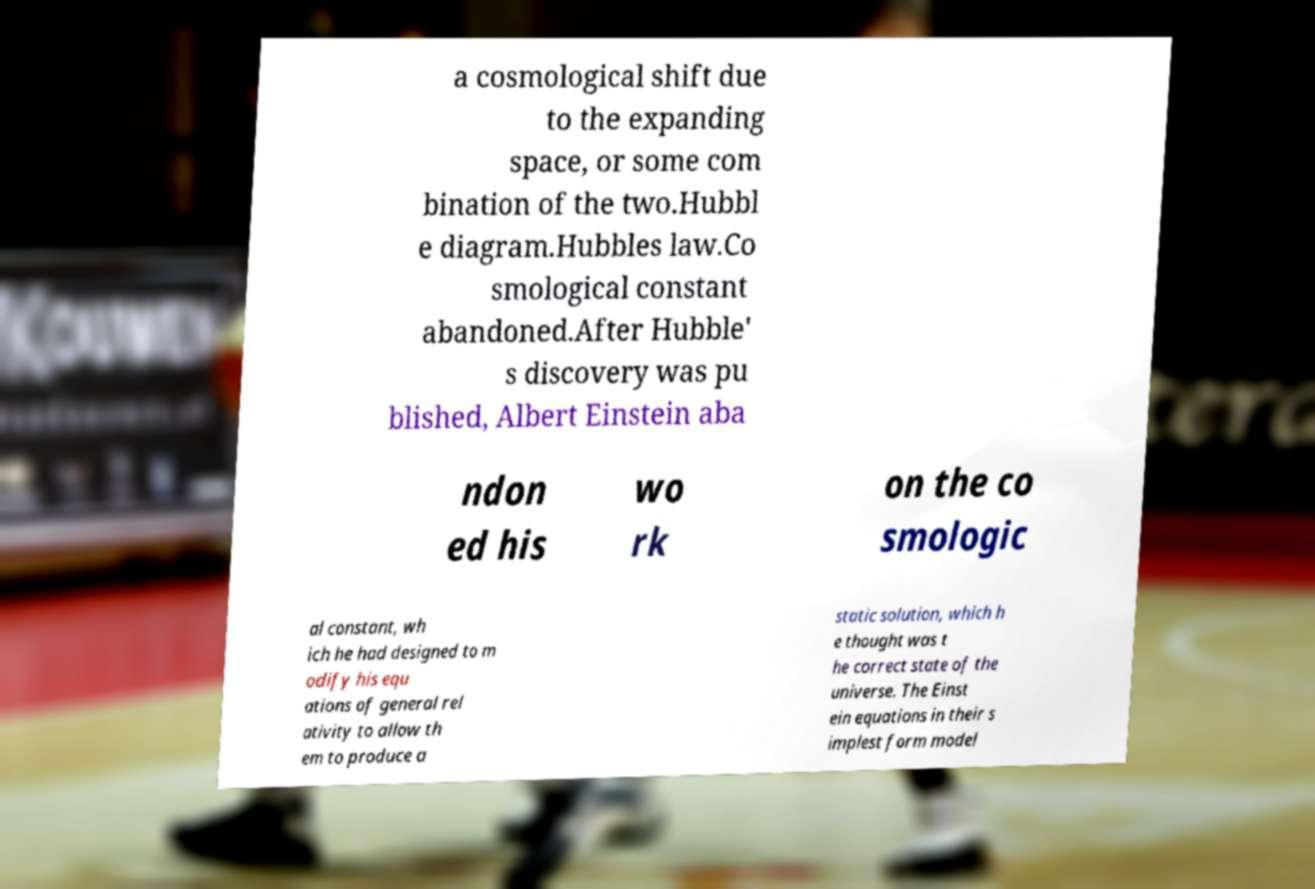I need the written content from this picture converted into text. Can you do that? a cosmological shift due to the expanding space, or some com bination of the two.Hubbl e diagram.Hubbles law.Co smological constant abandoned.After Hubble' s discovery was pu blished, Albert Einstein aba ndon ed his wo rk on the co smologic al constant, wh ich he had designed to m odify his equ ations of general rel ativity to allow th em to produce a static solution, which h e thought was t he correct state of the universe. The Einst ein equations in their s implest form model 